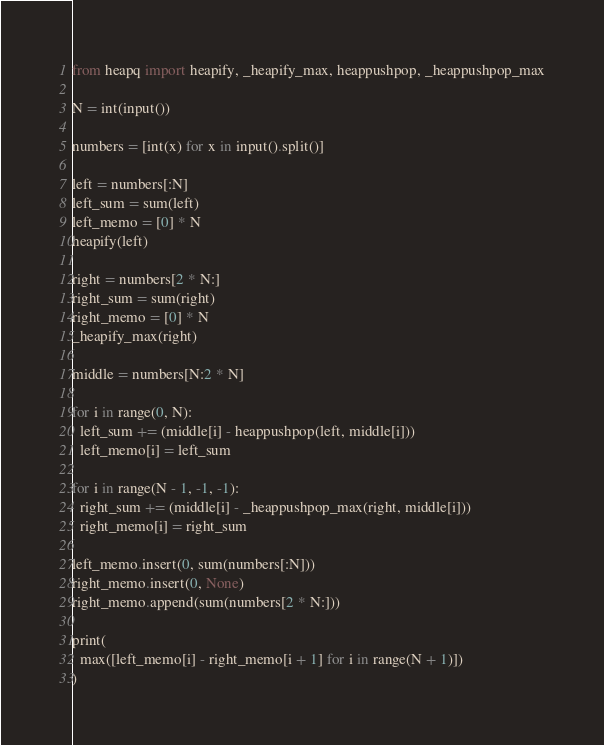Convert code to text. <code><loc_0><loc_0><loc_500><loc_500><_Python_>from heapq import heapify, _heapify_max, heappushpop, _heappushpop_max

N = int(input())

numbers = [int(x) for x in input().split()]

left = numbers[:N]
left_sum = sum(left)
left_memo = [0] * N
heapify(left)

right = numbers[2 * N:]
right_sum = sum(right)
right_memo = [0] * N
_heapify_max(right)

middle = numbers[N:2 * N]

for i in range(0, N):
  left_sum += (middle[i] - heappushpop(left, middle[i]))
  left_memo[i] = left_sum

for i in range(N - 1, -1, -1):
  right_sum += (middle[i] - _heappushpop_max(right, middle[i]))
  right_memo[i] = right_sum

left_memo.insert(0, sum(numbers[:N]))
right_memo.insert(0, None)
right_memo.append(sum(numbers[2 * N:]))
    
print(
  max([left_memo[i] - right_memo[i + 1] for i in range(N + 1)])
)</code> 